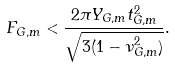Convert formula to latex. <formula><loc_0><loc_0><loc_500><loc_500>F _ { G , m } < \frac { 2 \pi Y _ { G , m } t _ { G , m } ^ { 2 } } { \sqrt { 3 ( 1 - \nu _ { G , m } ^ { 2 } ) } } .</formula> 